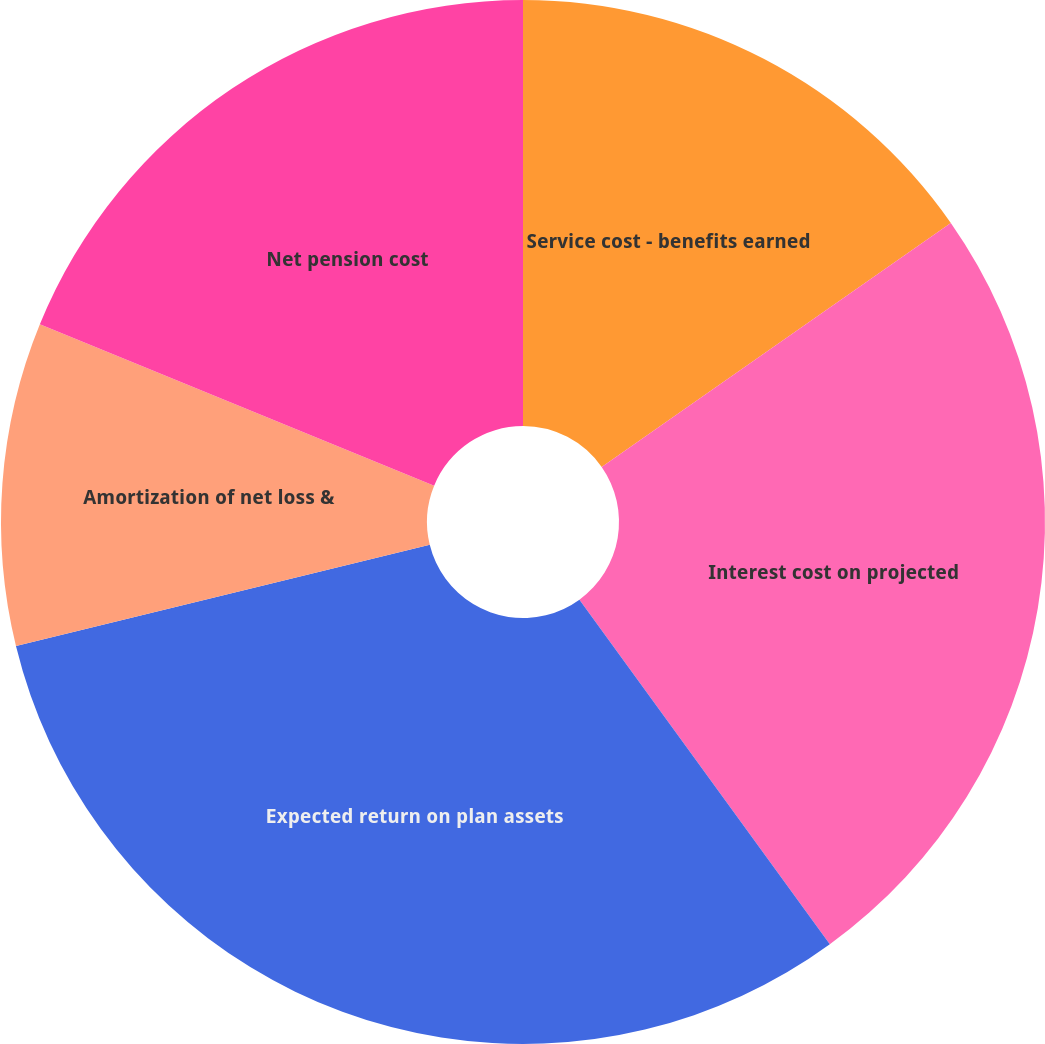Convert chart to OTSL. <chart><loc_0><loc_0><loc_500><loc_500><pie_chart><fcel>Service cost - benefits earned<fcel>Interest cost on projected<fcel>Expected return on plan assets<fcel>Amortization of net loss &<fcel>Net pension cost<nl><fcel>15.29%<fcel>24.71%<fcel>31.18%<fcel>10.0%<fcel>18.82%<nl></chart> 